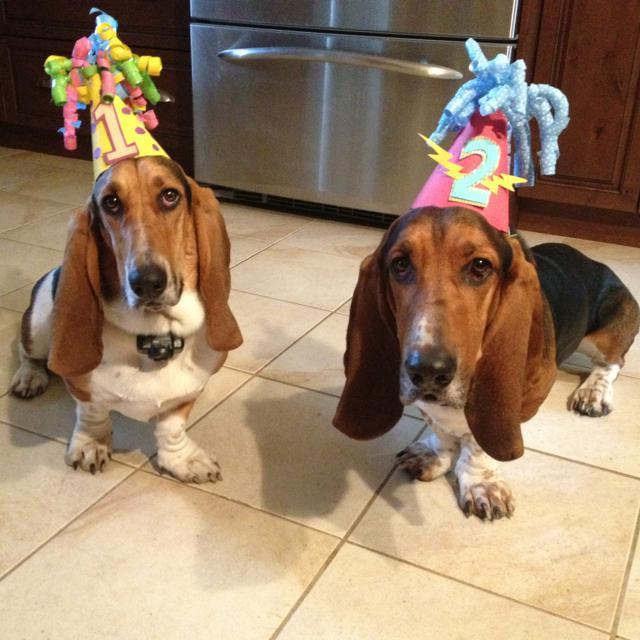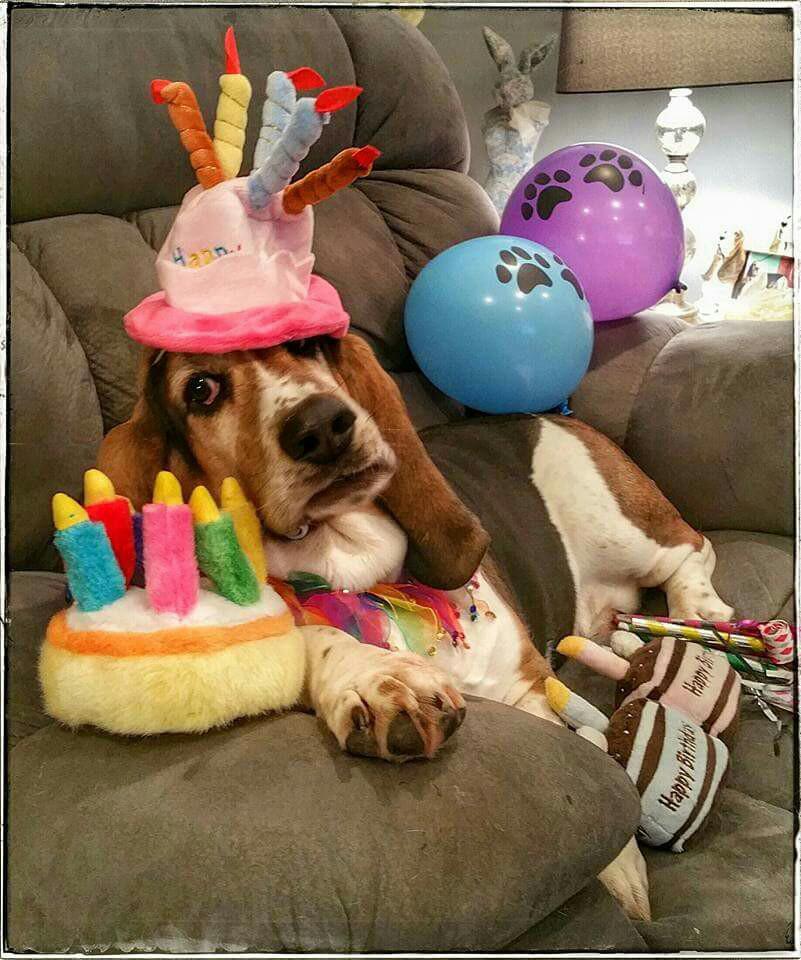The first image is the image on the left, the second image is the image on the right. Examine the images to the left and right. Is the description "One of the dogs is lying on a couch." accurate? Answer yes or no. Yes. 